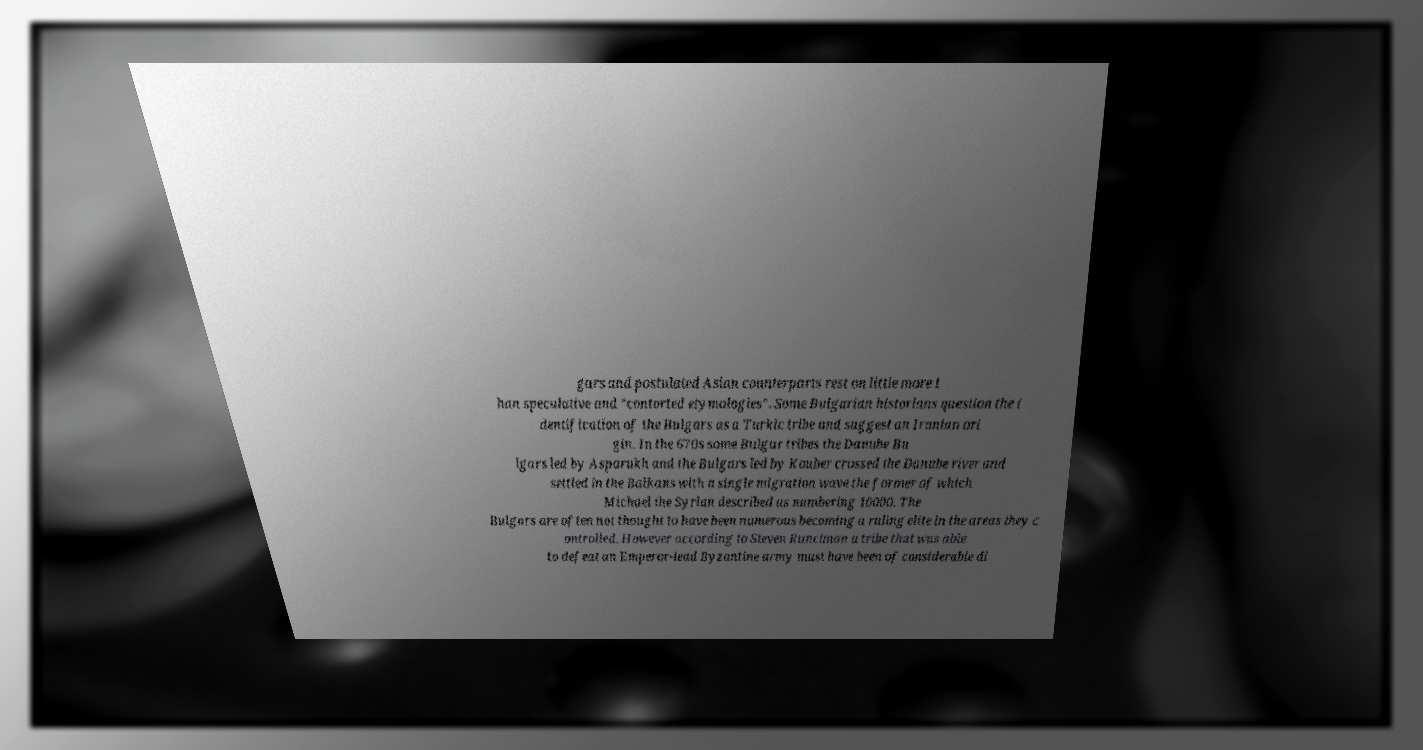What messages or text are displayed in this image? I need them in a readable, typed format. gars and postulated Asian counterparts rest on little more t han speculative and "contorted etymologies". Some Bulgarian historians question the i dentification of the Bulgars as a Turkic tribe and suggest an Iranian ori gin. In the 670s some Bulgar tribes the Danube Bu lgars led by Asparukh and the Bulgars led by Kouber crossed the Danube river and settled in the Balkans with a single migration wave the former of which Michael the Syrian described as numbering 10000. The Bulgars are often not thought to have been numerous becoming a ruling elite in the areas they c ontrolled. However according to Steven Runciman a tribe that was able to defeat an Emperor-lead Byzantine army must have been of considerable di 